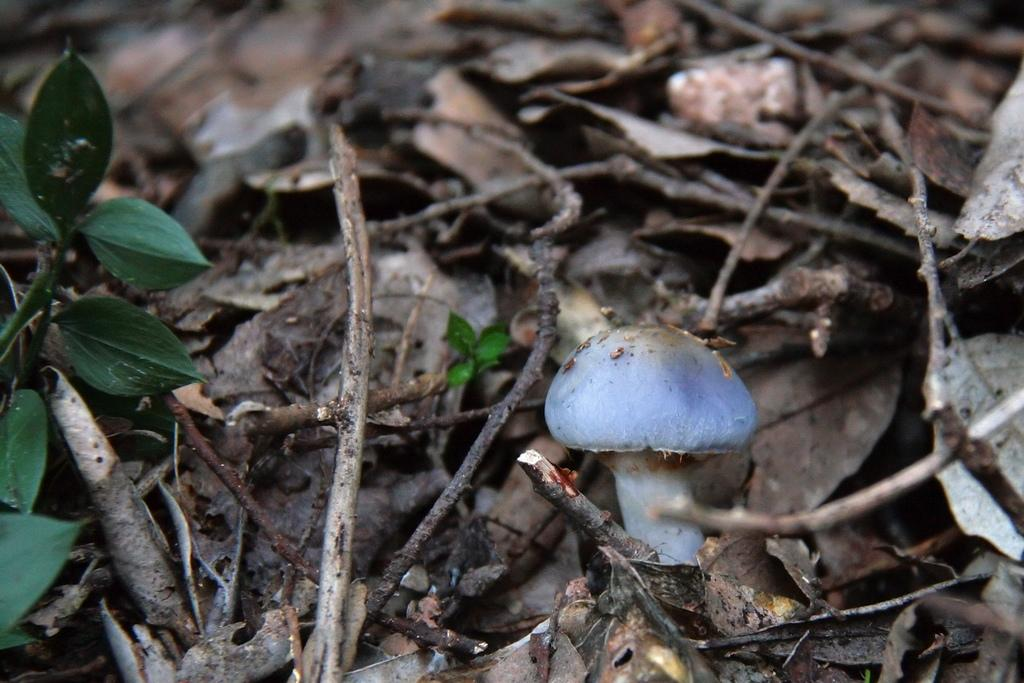What is the main subject in the middle of the image? There is a mushroom in the middle of the image. What other objects can be seen in the image? There are dried sticks and leaves in the image. Where is the green plant located in the image? The green plant is on the left side of the image. What type of pear can be seen hanging from the green plant in the image? There is no pear present in the image; it features a mushroom, dried sticks, leaves, and a green plant. What behavior can be observed in the mushroom in the image? The mushroom is not capable of exhibiting behavior, as it is an inanimate object. 